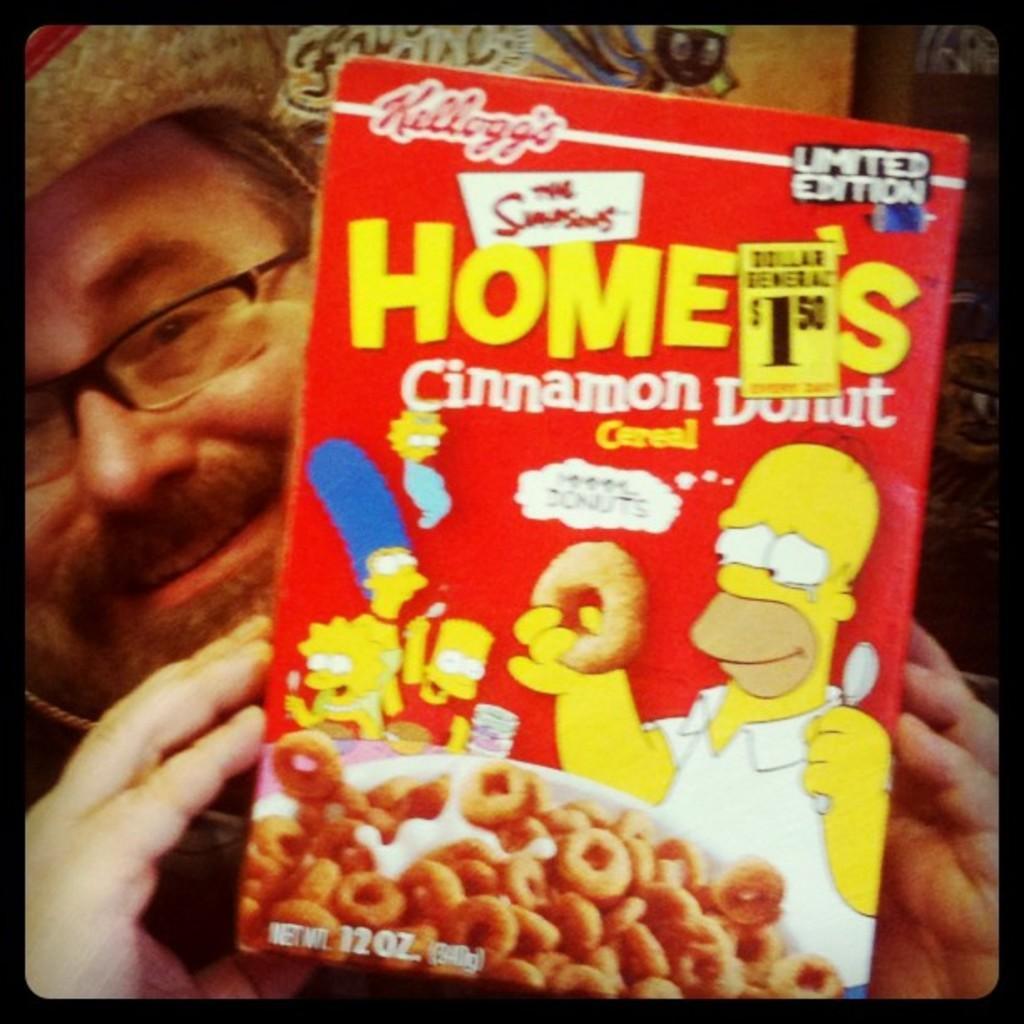Could you give a brief overview of what you see in this image? In this picture, we see the man who is wearing spectacles and a hat is holding a red color doughnut box in his hands. He is smiling. This might be an edited image. 